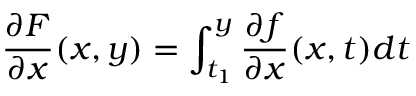Convert formula to latex. <formula><loc_0><loc_0><loc_500><loc_500>{ \frac { \partial F } { \partial x } } ( x , y ) = \int _ { t _ { 1 } } ^ { y } { \frac { \partial f } { \partial x } } ( x , t ) d t</formula> 